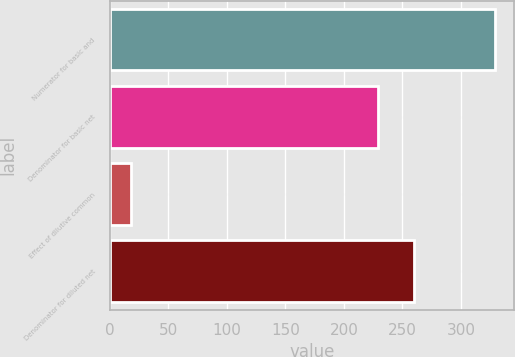Convert chart to OTSL. <chart><loc_0><loc_0><loc_500><loc_500><bar_chart><fcel>Numerator for basic and<fcel>Denominator for basic net<fcel>Effect of dilutive common<fcel>Denominator for diluted net<nl><fcel>328.9<fcel>229<fcel>18.5<fcel>260.04<nl></chart> 